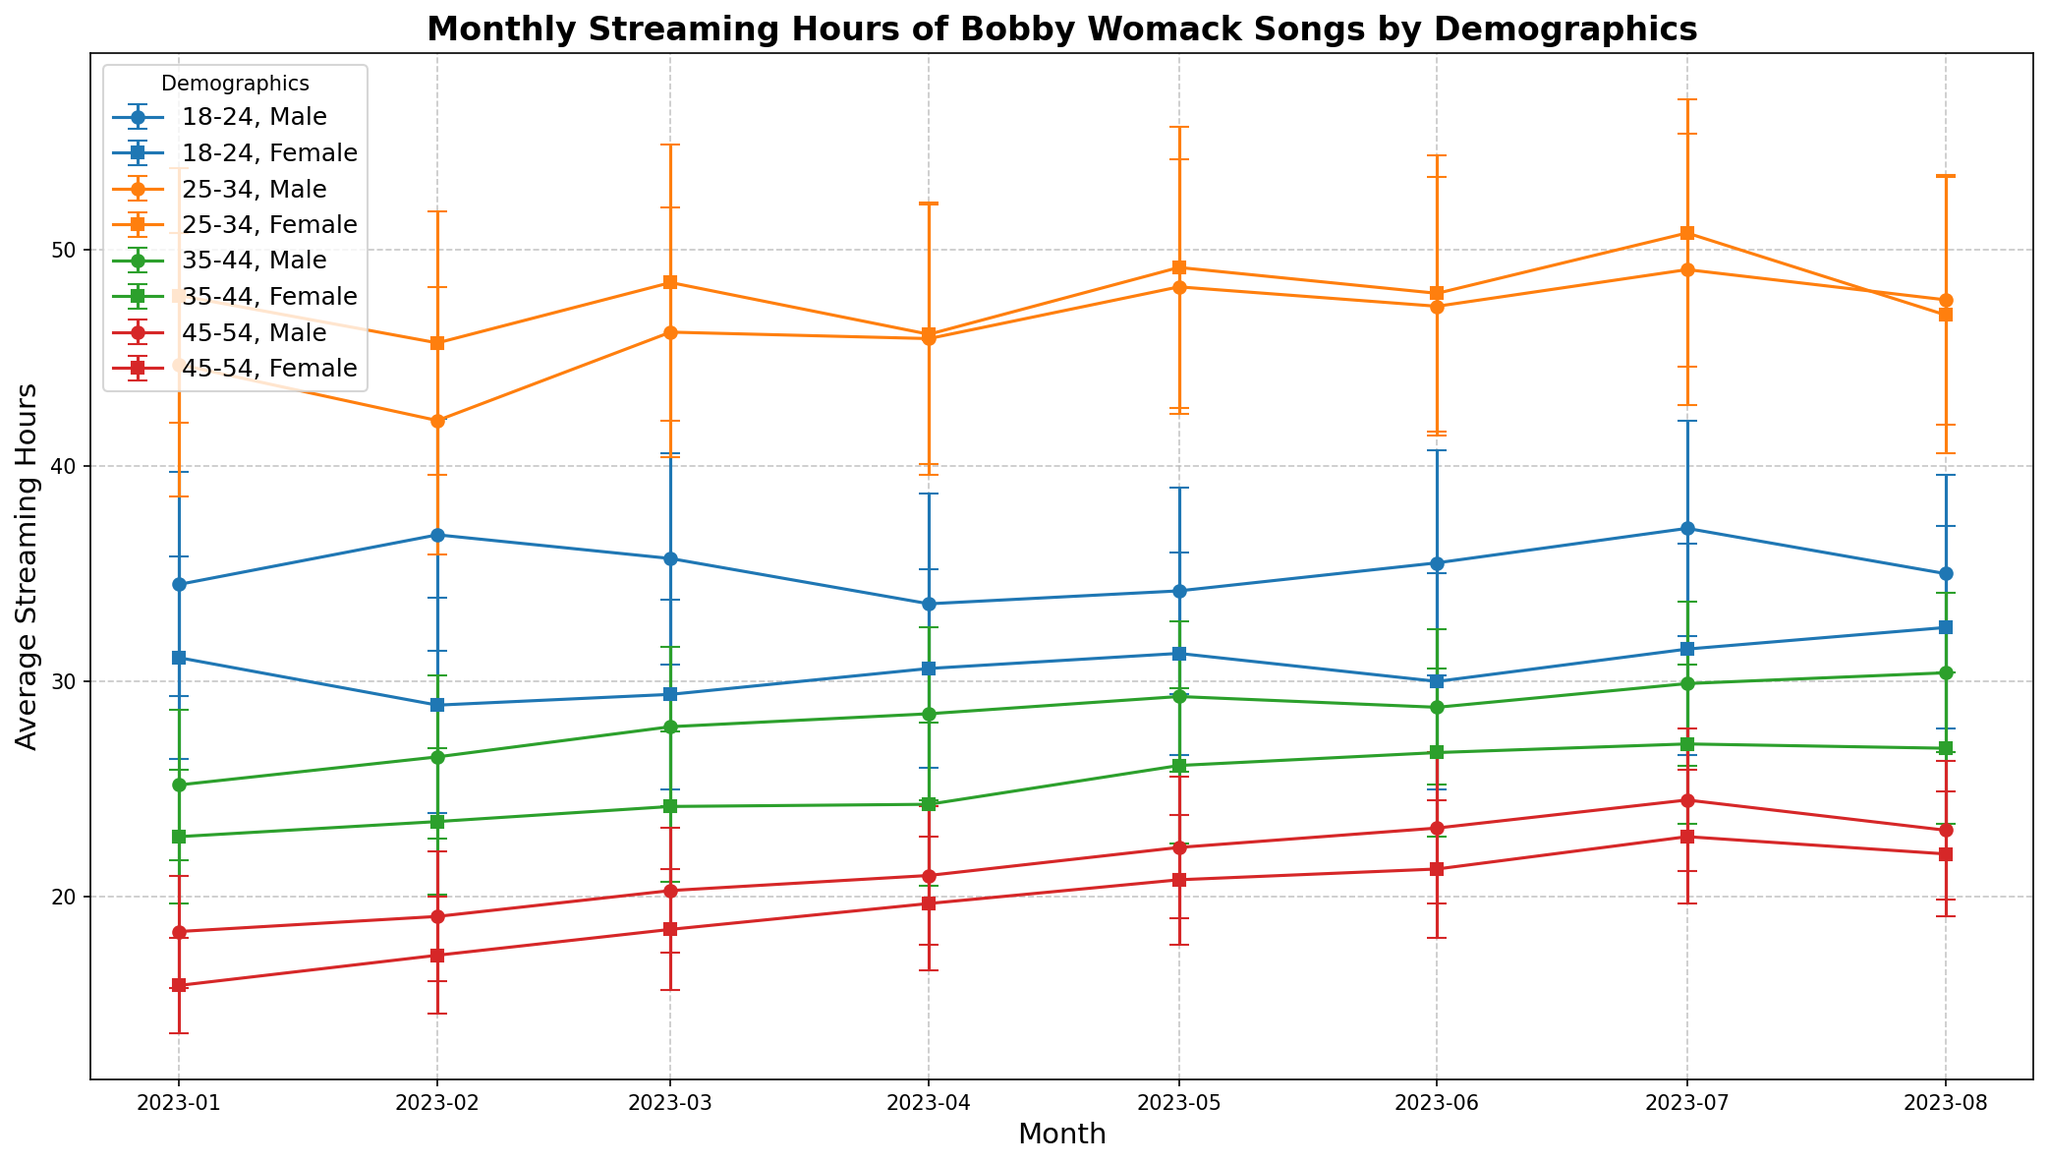What is the trend in average streaming hours for the 18-24 age group over the months? To determine the trend, observe the series of data points for the 18-24 age group across each month in the figure. Notice how the average streaming hours shift from month to month.
Answer: The average streaming hours fluctuate slightly but generally remain around 33-37 hours monthly How do the average streaming hours of females aged 25-34 in February compare to the past month and subsequent month? By comparing the data points for females aged 25-34 in January, February, and March, you can analyze the monthly averages.
Answer: The average streaming hours in February (45.7) are slightly lower than January (47.9) but higher than in March (48.5) Which age and gender group show the highest average streaming hours in July, and what is the value? Look for the peak data point in July and identify the corresponding age and gender group.
Answer: Females aged 25-34 show the highest average streaming hours in July with 50.8 hours What is the difference in average streaming hours between 18-24 males and females in June? Look at the June data for both 18-24 males and females, then subtract the female's value from the male's value to find the difference.
Answer: The difference is 35.5 - 30.0 = 5.5 hours Which demographic shows the most variability in their streaming hours across the months? Identify the group with the largest fluctuations in their error bars (standard deviations) over the months.
Answer: Males aged 25-34 show the most variability How have the streaming hours for the 45-54 female demographic changed from January to August? Observe the sequence of data points for the 45-54 female group from January to August and note any increases or decreases.
Answer: Streaming hours for 45-54 females increased from 15.9 in January to 22.0 in August Are the average streaming hours for 35-44 males higher in April or May? Compare the average streaming hours of 35-44 males in April and May.
Answer: May (29.3 hours) has higher streaming than April (28.5 hours) What colors represent the age group 25-34 in the plot? Identify the colors used for the data points representing the 25-34 age group throughout the months.
Answer: The color used is either "tab:orange" In which month do 18-24 females have the lowest average streaming hours, and what is the value? Find the lowest data point for 18-24 females across all months and note the corresponding month and value.
Answer: The lowest average streaming hours for 18-24 females are in February at 28.9 hours What is the average of the average streaming hours for 35-44 females in January and February combined? Add the average streaming hours for 35-44 females in January and February and divide by two.
Answer: (22.8 + 23.5)/2 = 23.15 hours 